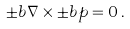Convert formula to latex. <formula><loc_0><loc_0><loc_500><loc_500>\pm b { \nabla } \times \pm b { p } = 0 \, .</formula> 